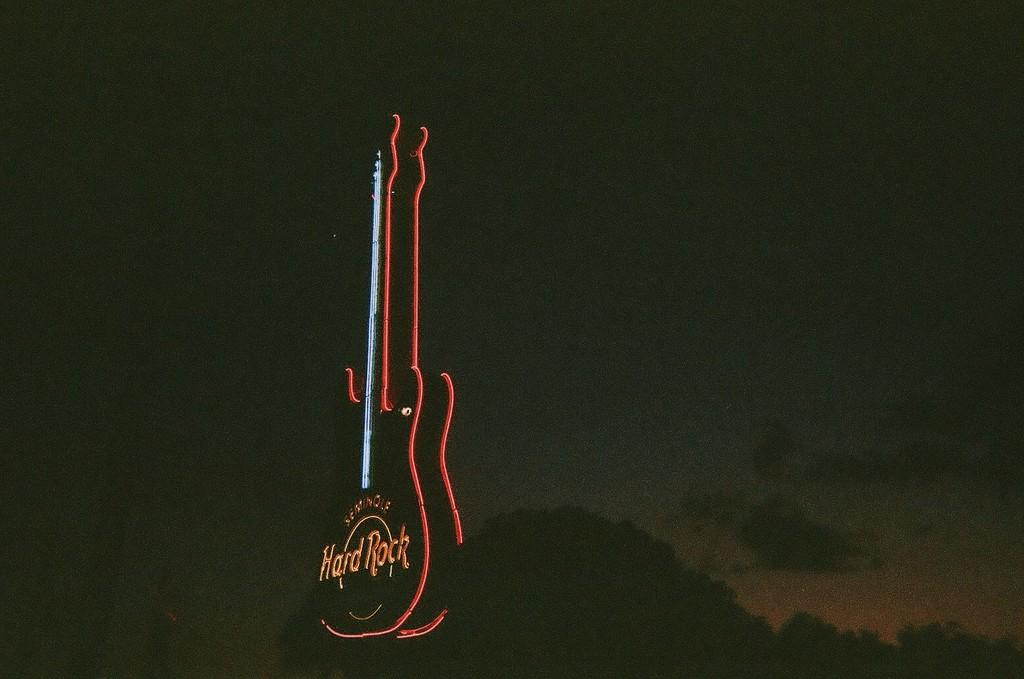What is the main object in the image that has a neon light? There is a neon light in the shape of a guitar in the image. What can be seen in the background of the image? There appears to be a tree in the background of the image. What is visible above the tree in the image? The sky is visible above the tree in the image. What type of theory is being discussed in the image? There is no discussion or reference to any theory in the image; it primarily features a neon light guitar and a tree in the background. 